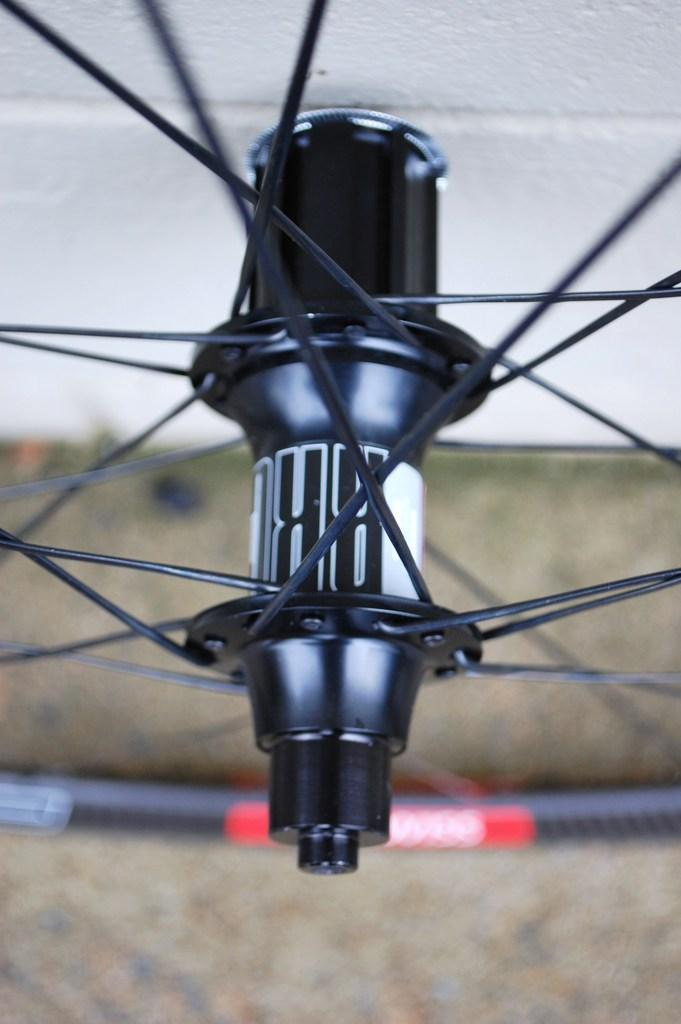What is the main object in the image? There is a wheel of a cycle in the image. What can be seen in the background of the image? There is a wall in the background of the image. Can you see an owl in the image? There is no owl present in the image. Is the cycle in the image capable of flight? The image only shows a wheel of a cycle, and it is not possible to determine if the entire cycle is capable of flight based on this information. 